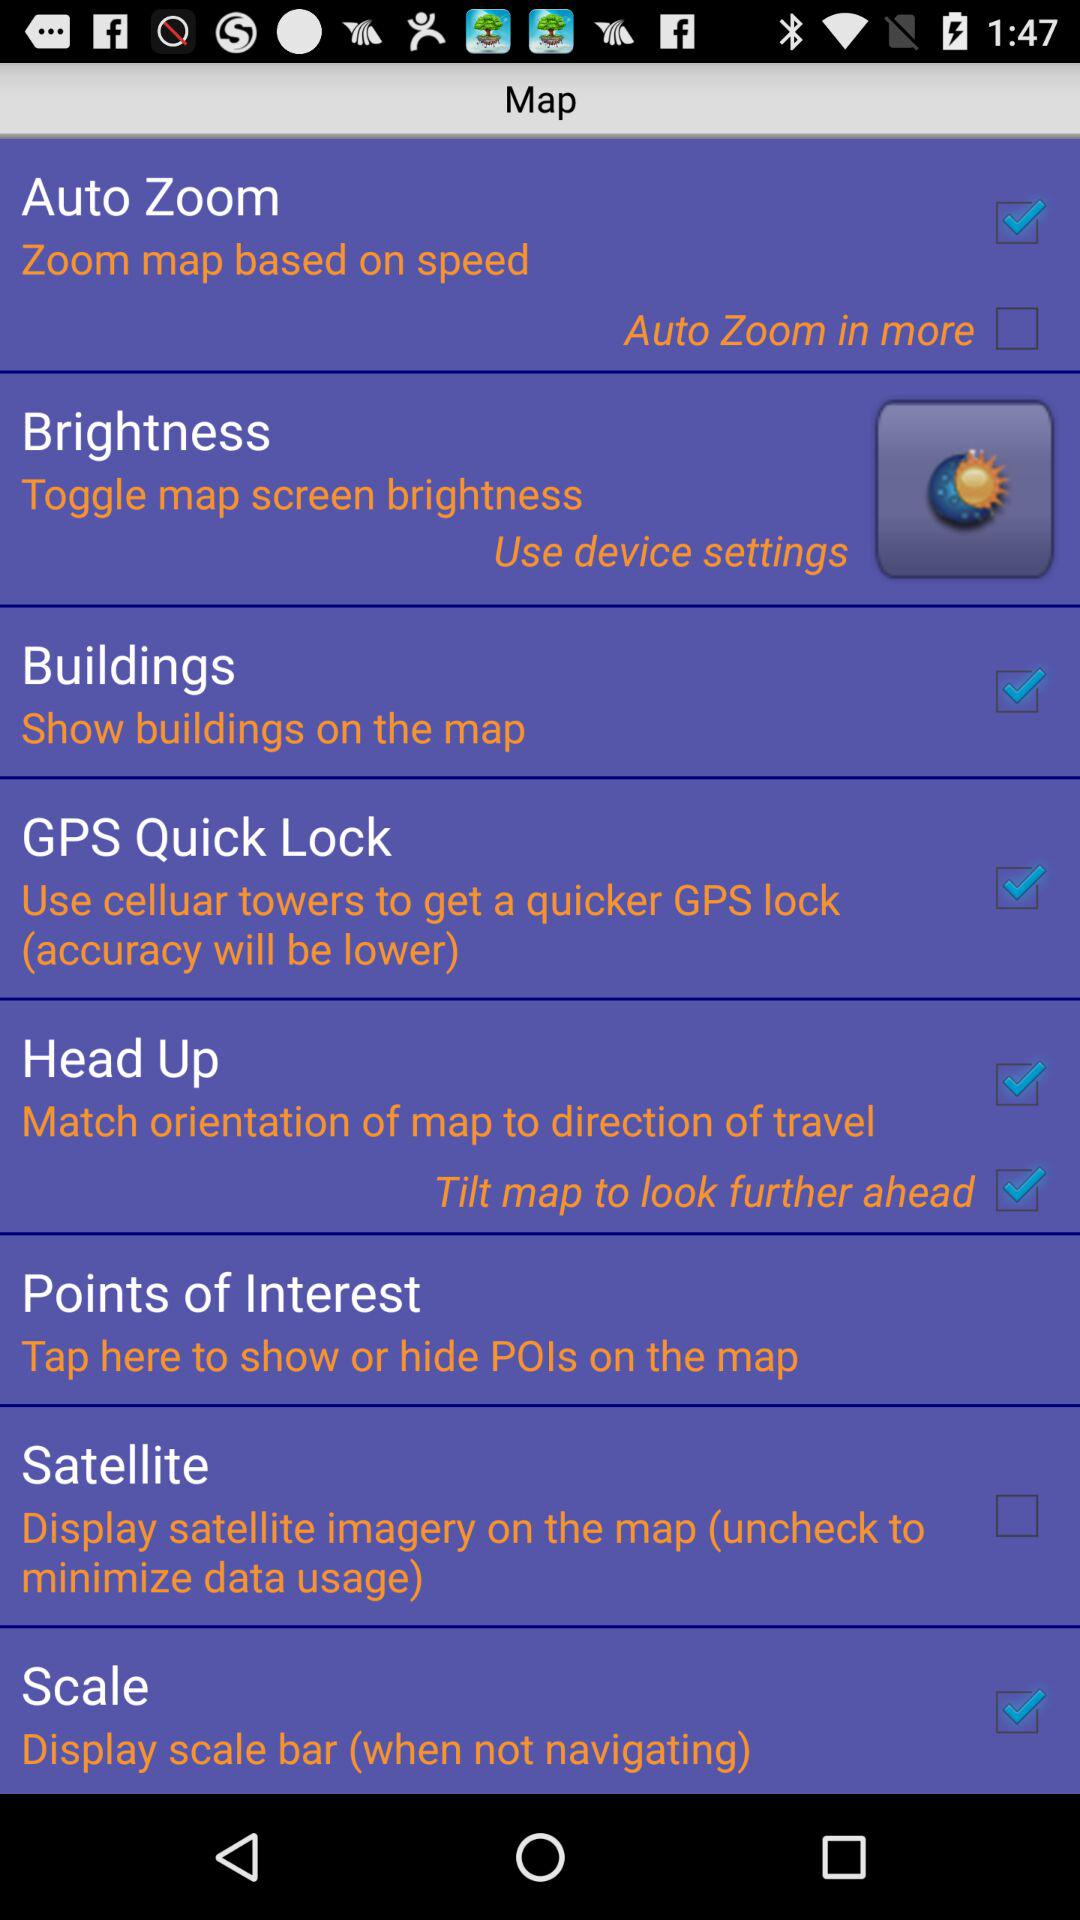What is the status of the buildings? The status is on. 